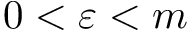Convert formula to latex. <formula><loc_0><loc_0><loc_500><loc_500>0 < \varepsilon < m</formula> 